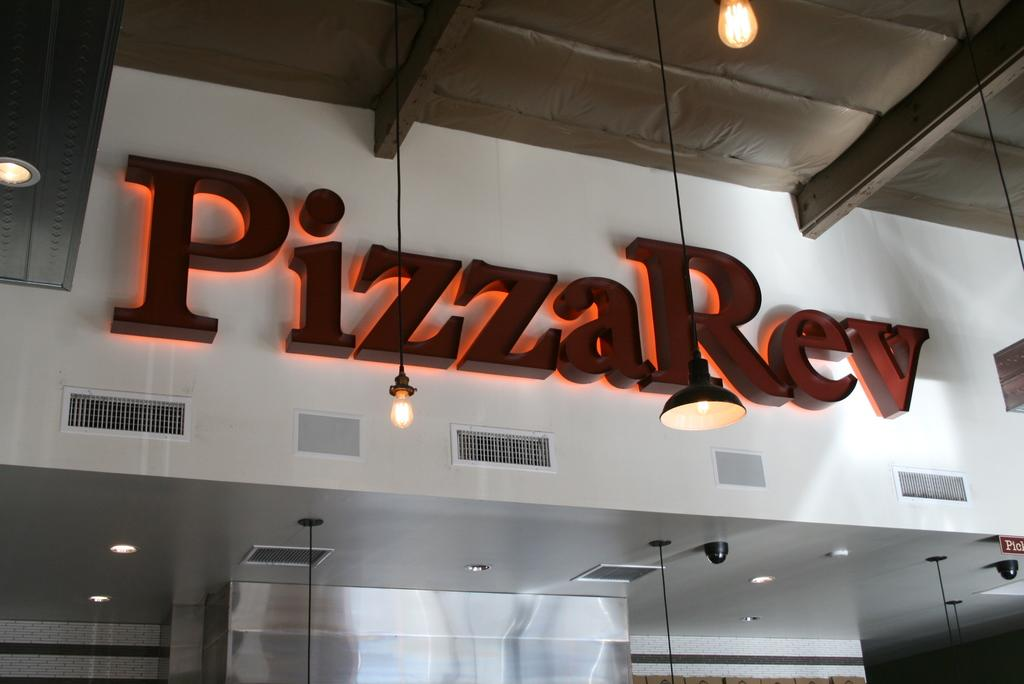What can be seen hanging in the image? Lights are hanging in the image. What is the main feature of the store in the image? There is a LED name board of a store in the image. What is written on the name board? The name board has 'pizzarev' written on it. Can you hear the crow's call in the image? There is no auditory component in the image, and therefore no sounds can be heard. How many bananas are displayed on the name board? There are no bananas present on the name board; it only has 'pizzarev' written on it. 